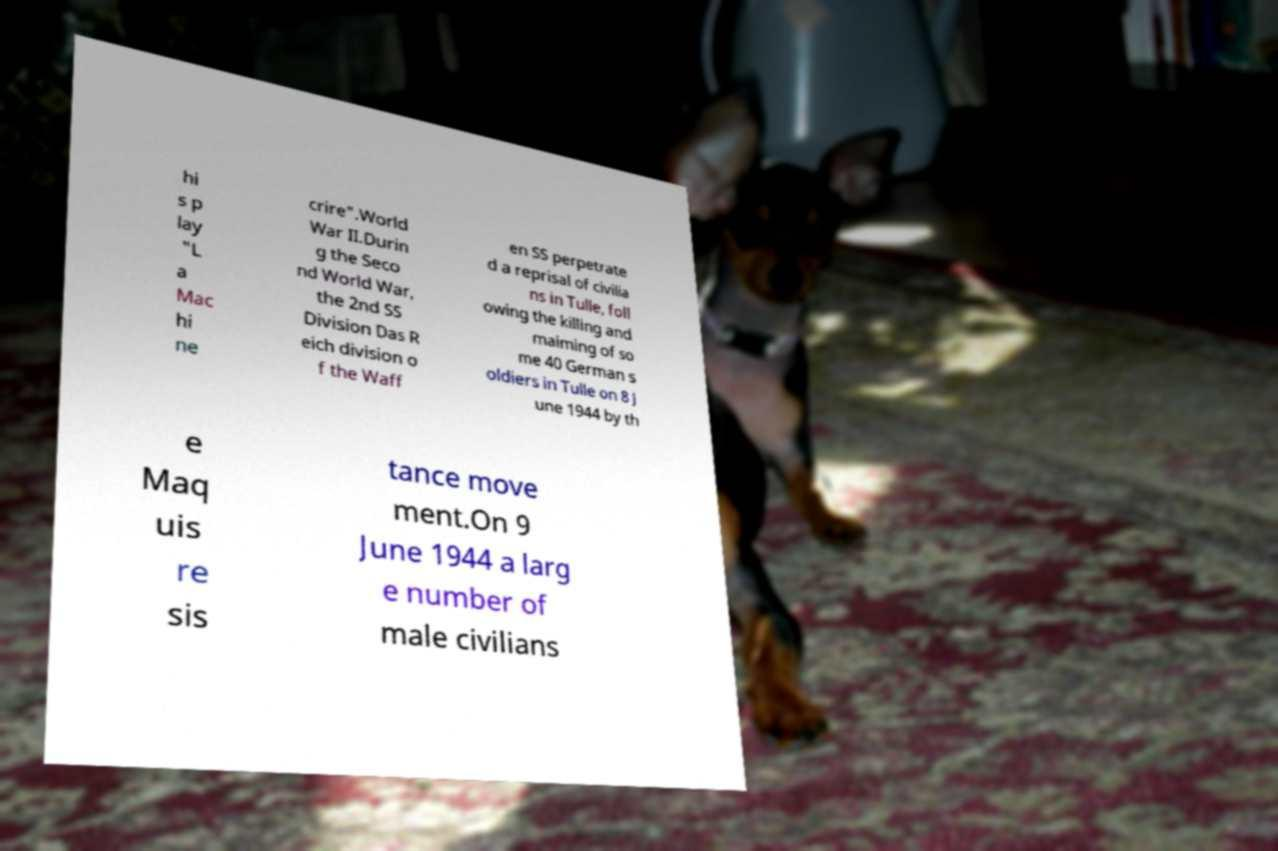Could you assist in decoding the text presented in this image and type it out clearly? hi s p lay "L a Mac hi ne crire".World War II.Durin g the Seco nd World War, the 2nd SS Division Das R eich division o f the Waff en SS perpetrate d a reprisal of civilia ns in Tulle, foll owing the killing and maiming of so me 40 German s oldiers in Tulle on 8 J une 1944 by th e Maq uis re sis tance move ment.On 9 June 1944 a larg e number of male civilians 